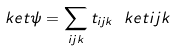Convert formula to latex. <formula><loc_0><loc_0><loc_500><loc_500>\ k e t { \psi } = \sum _ { i j k } { t _ { i j k } \ k e t { i j k } }</formula> 